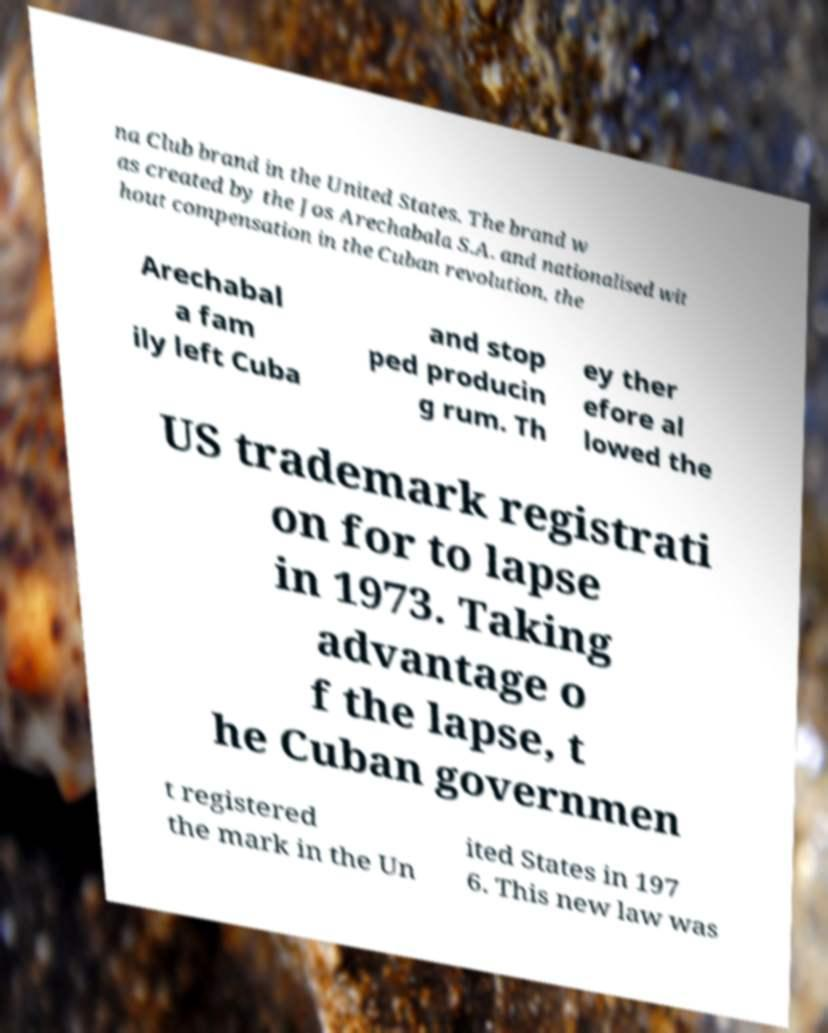For documentation purposes, I need the text within this image transcribed. Could you provide that? na Club brand in the United States. The brand w as created by the Jos Arechabala S.A. and nationalised wit hout compensation in the Cuban revolution, the Arechabal a fam ily left Cuba and stop ped producin g rum. Th ey ther efore al lowed the US trademark registrati on for to lapse in 1973. Taking advantage o f the lapse, t he Cuban governmen t registered the mark in the Un ited States in 197 6. This new law was 